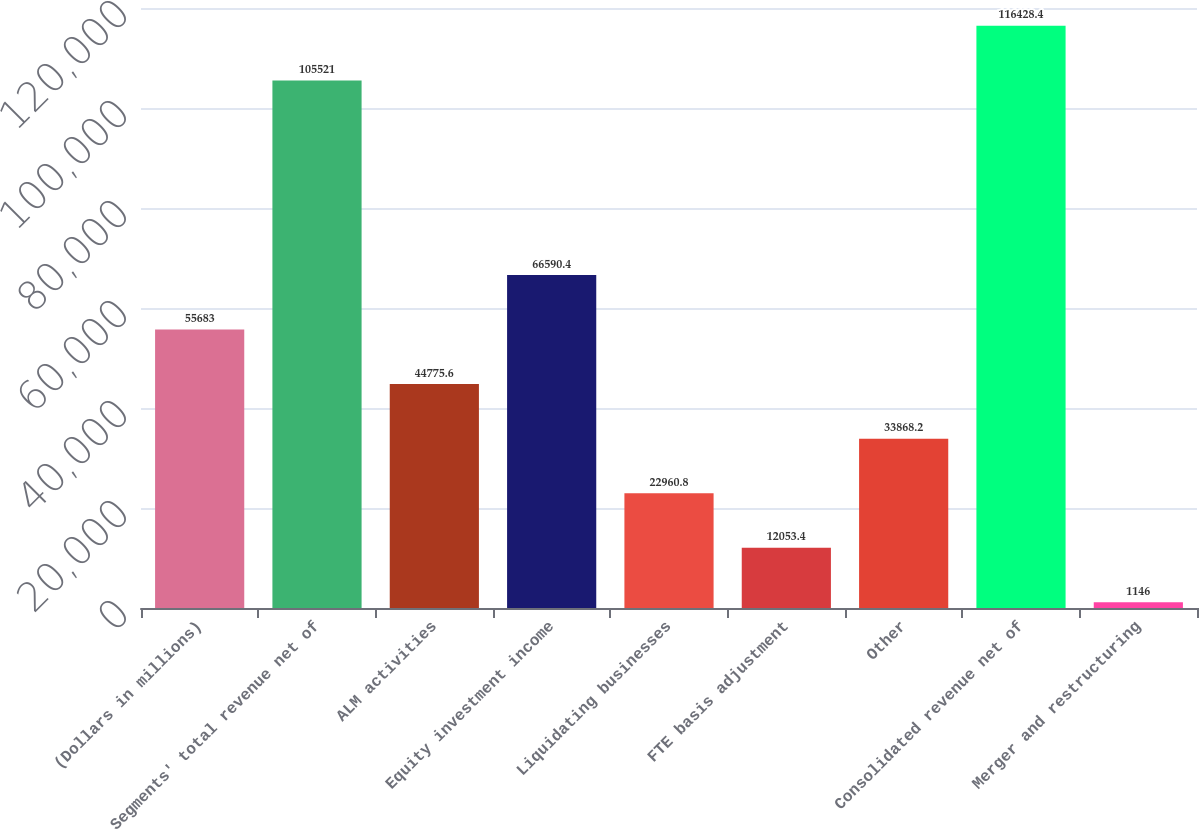Convert chart. <chart><loc_0><loc_0><loc_500><loc_500><bar_chart><fcel>(Dollars in millions)<fcel>Segments' total revenue net of<fcel>ALM activities<fcel>Equity investment income<fcel>Liquidating businesses<fcel>FTE basis adjustment<fcel>Other<fcel>Consolidated revenue net of<fcel>Merger and restructuring<nl><fcel>55683<fcel>105521<fcel>44775.6<fcel>66590.4<fcel>22960.8<fcel>12053.4<fcel>33868.2<fcel>116428<fcel>1146<nl></chart> 